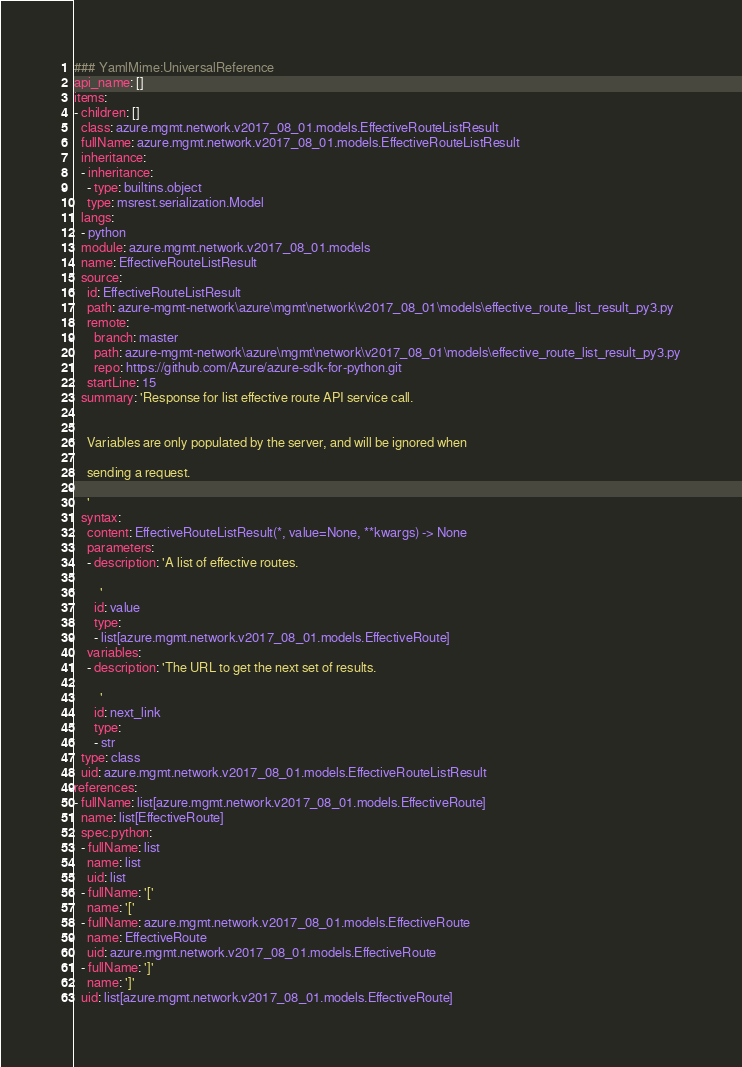<code> <loc_0><loc_0><loc_500><loc_500><_YAML_>### YamlMime:UniversalReference
api_name: []
items:
- children: []
  class: azure.mgmt.network.v2017_08_01.models.EffectiveRouteListResult
  fullName: azure.mgmt.network.v2017_08_01.models.EffectiveRouteListResult
  inheritance:
  - inheritance:
    - type: builtins.object
    type: msrest.serialization.Model
  langs:
  - python
  module: azure.mgmt.network.v2017_08_01.models
  name: EffectiveRouteListResult
  source:
    id: EffectiveRouteListResult
    path: azure-mgmt-network\azure\mgmt\network\v2017_08_01\models\effective_route_list_result_py3.py
    remote:
      branch: master
      path: azure-mgmt-network\azure\mgmt\network\v2017_08_01\models\effective_route_list_result_py3.py
      repo: https://github.com/Azure/azure-sdk-for-python.git
    startLine: 15
  summary: 'Response for list effective route API service call.


    Variables are only populated by the server, and will be ignored when

    sending a request.

    '
  syntax:
    content: EffectiveRouteListResult(*, value=None, **kwargs) -> None
    parameters:
    - description: 'A list of effective routes.

        '
      id: value
      type:
      - list[azure.mgmt.network.v2017_08_01.models.EffectiveRoute]
    variables:
    - description: 'The URL to get the next set of results.

        '
      id: next_link
      type:
      - str
  type: class
  uid: azure.mgmt.network.v2017_08_01.models.EffectiveRouteListResult
references:
- fullName: list[azure.mgmt.network.v2017_08_01.models.EffectiveRoute]
  name: list[EffectiveRoute]
  spec.python:
  - fullName: list
    name: list
    uid: list
  - fullName: '['
    name: '['
  - fullName: azure.mgmt.network.v2017_08_01.models.EffectiveRoute
    name: EffectiveRoute
    uid: azure.mgmt.network.v2017_08_01.models.EffectiveRoute
  - fullName: ']'
    name: ']'
  uid: list[azure.mgmt.network.v2017_08_01.models.EffectiveRoute]
</code> 